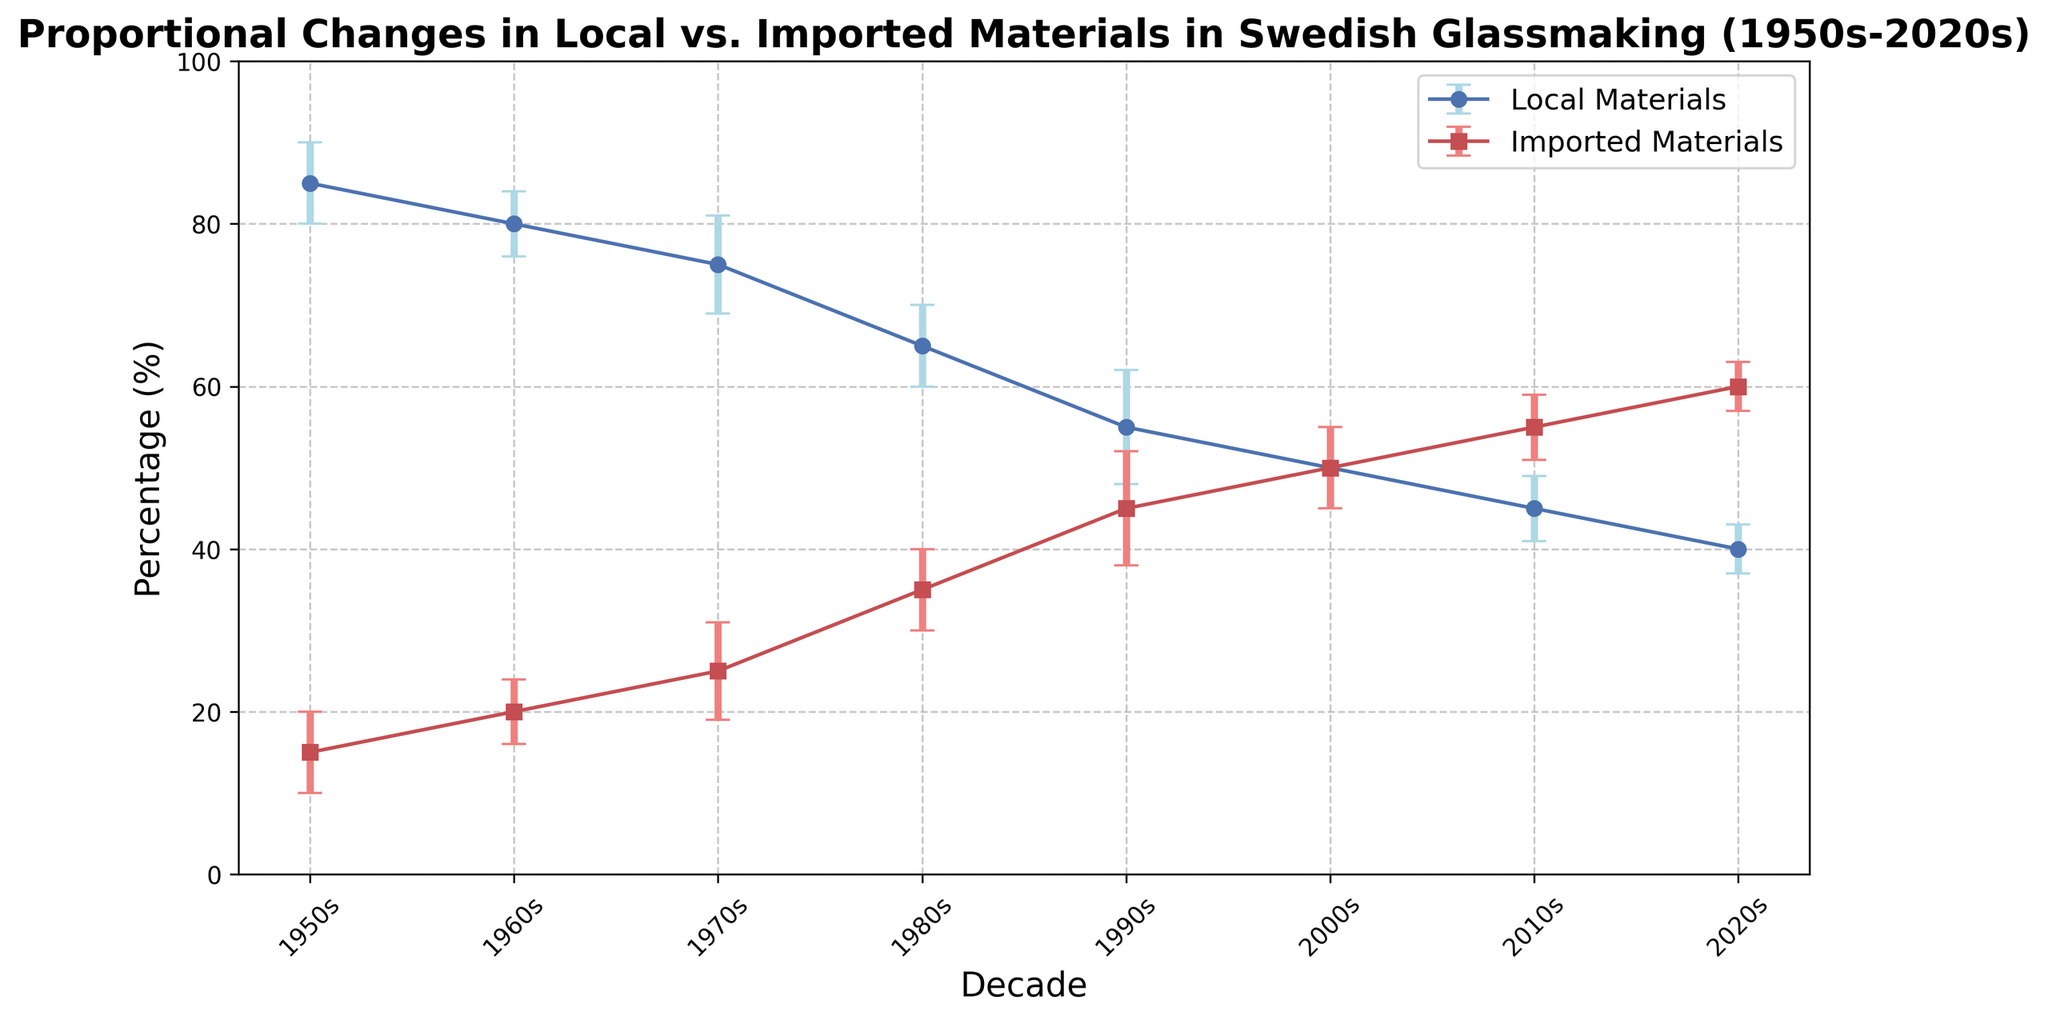What is the percentage of local materials used in the 1980s? Look at the blue line marked with circles for the 1980s. The local materials percentage is given as 65%
Answer: 65% In which decade does the use of imported materials reach 50%? Identify the red line marked with squares and find the point where it reaches 50%. This occurs in the 2000s.
Answer: 2000s How does the trend of local material usage change from the 1950s to the 2020s? Examine the blue line marked with circles. It shows a continuous decrease from 85% in the 1950s to 40% in the 2020s.
Answer: Decreases continuously What is the difference between the proportions of local and imported materials in the 1990s? In the 1990s, the percentage of local materials is 55% and imported materials is 45%. The difference is 55% - 45%.
Answer: 10% By how much does the percentage of local materials decrease from the 1970s to the 1990s? Subtract the local material percentage of the 1990s (55%) from that of the 1970s (75%). 75% - 55% = 20%
Answer: 20% During which decade does the error margin for local materials peak, and what is its value? Look at the blue error bars and identify that the largest error margin occurs in the 1990s, with a value of 7%.
Answer: 1990s, 7% Compare the error margins of imported materials between the 1950s and the 2020s. Which one is higher? The error margin for imported materials in the 1950s is 5% and in the 2020s, it is 3%. Thus, the 1950s has a higher error margin.
Answer: 1950s What is the average percentage of local materials used over the entire period from the 1950s to the 2020s? Add up the percentages of local materials (85 + 80 + 75 + 65 + 55 + 50 + 45 + 40) and divide by the number of decades (8). (85 + 80 + 75 + 65 + 55 + 50 + 45 + 40)/8 = 61.875%
Answer: 61.875% When did the proportion of imported materials first surpass 30%? Identify the red line marked with squares and find the decade when it first surpasses 30%. This occurs in the 1980s.
Answer: 1980s 